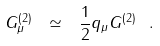Convert formula to latex. <formula><loc_0><loc_0><loc_500><loc_500>G _ { \mu } ^ { ( 2 ) } \ \simeq \ \frac { 1 } { 2 } q _ { \mu } G ^ { ( 2 ) } \ .</formula> 